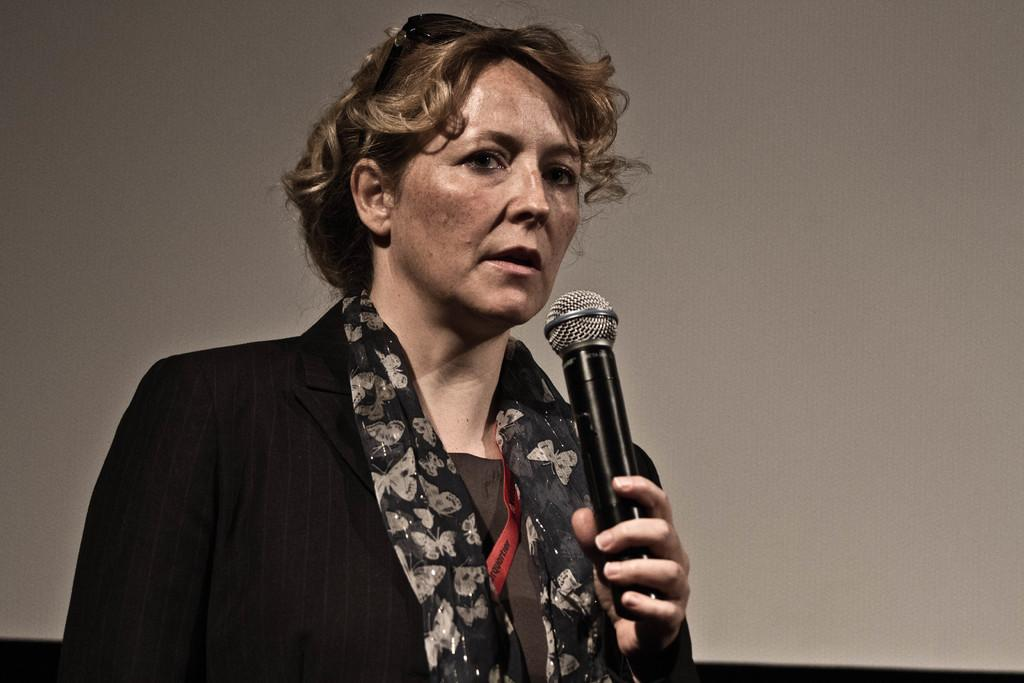What is the main subject of the image? There is a lady in the image. What is the lady doing in the image? The lady is standing and holding a mic. What is the lady wearing in the image? The lady is wearing a jacket. What can be seen in the background of the image? There is a wall in the background of the image. What type of sponge can be seen on the lady's head in the image? There is no sponge present on the lady's head in the image. What fruit is the lady holding in her hand instead of a mic? The lady is not holding a fruit in her hand; she is holding a mic. 